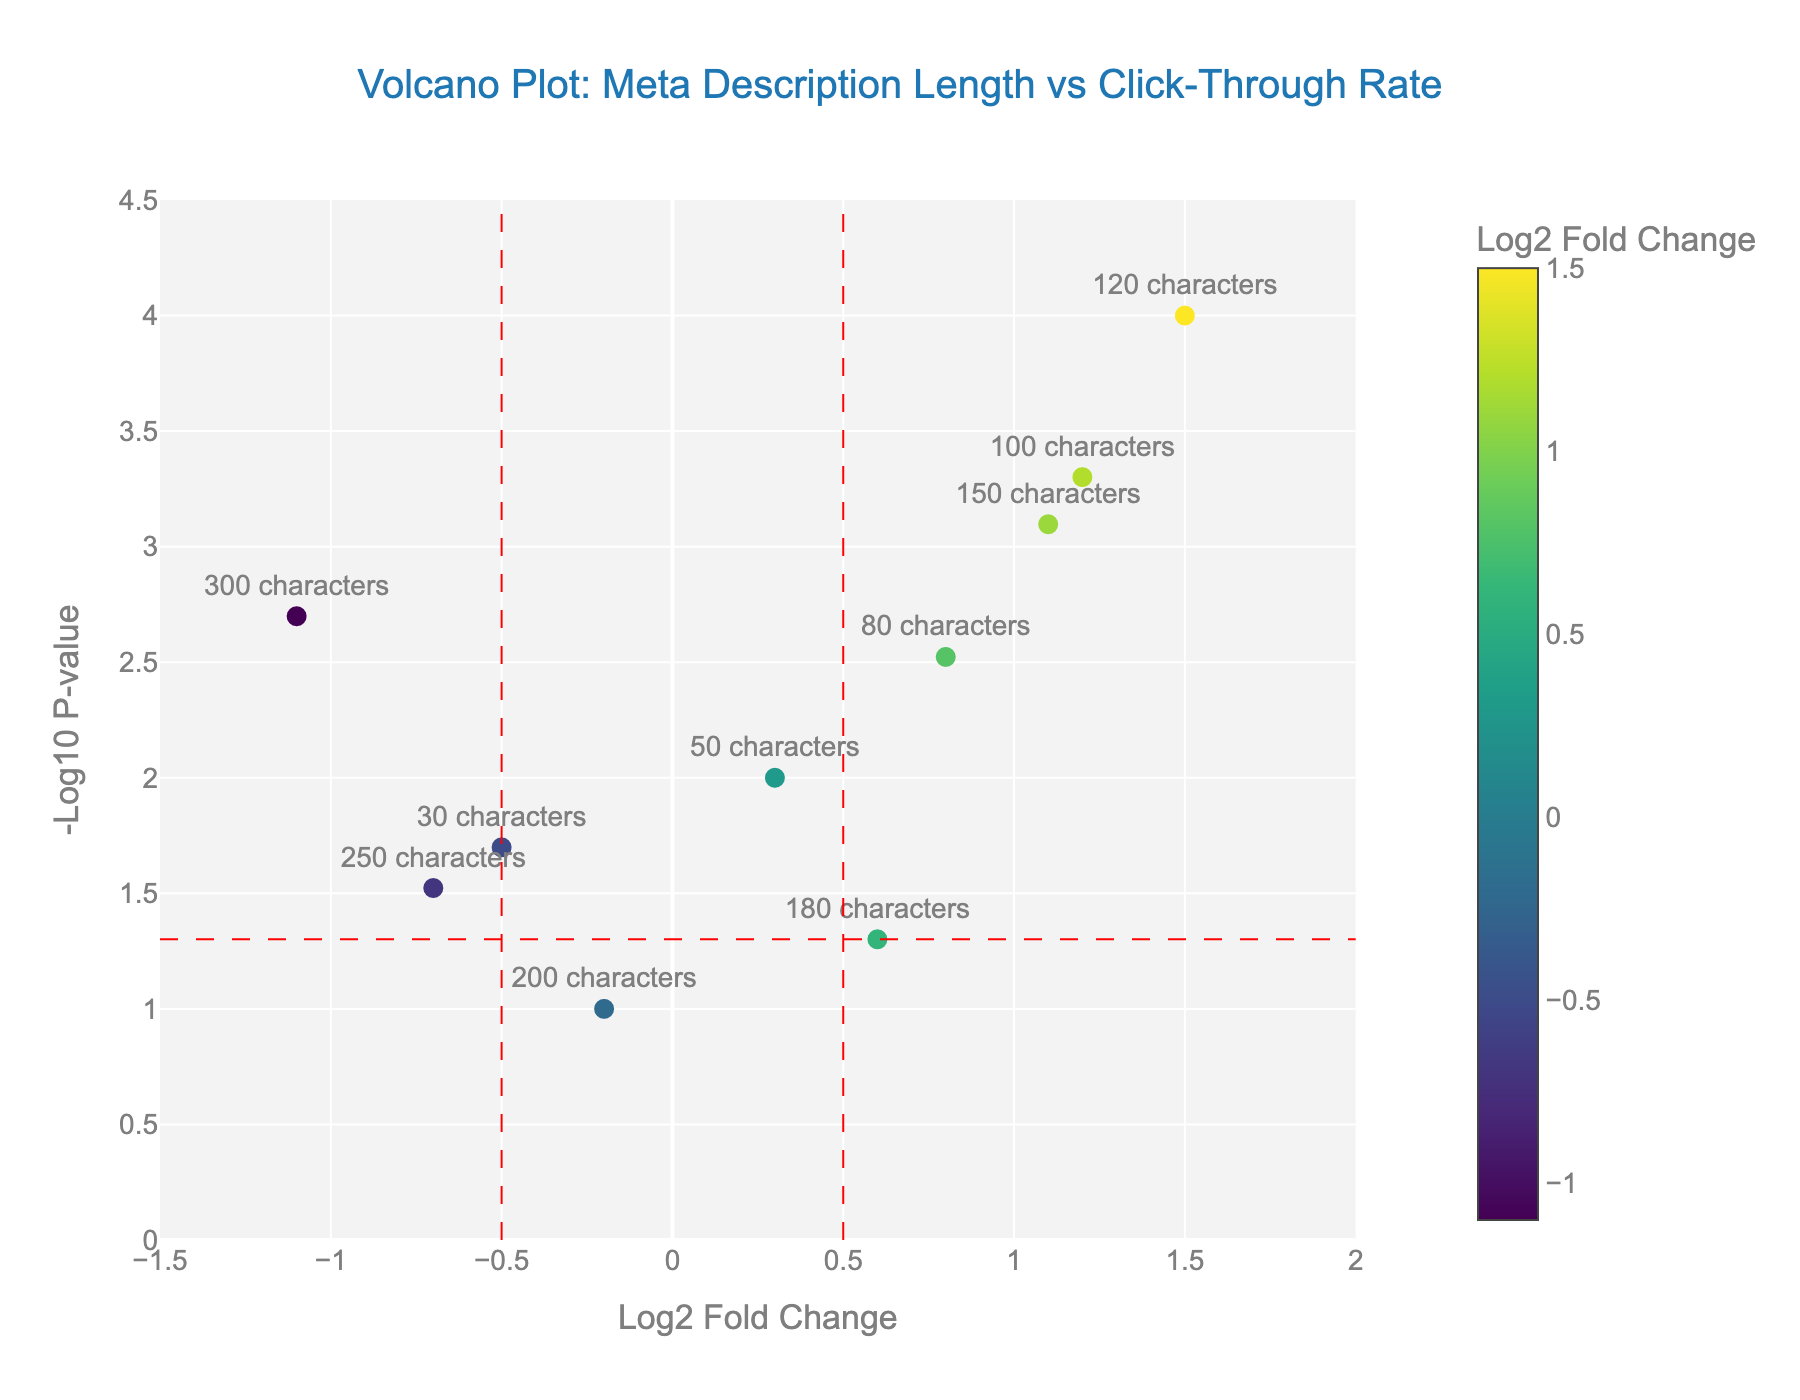What is the title of the plot? The title of the plot is displayed at the top center. In this case, it reads "Volcano Plot: Meta Description Length vs Click-Through Rate".
Answer: Volcano Plot: Meta Description Length vs Click-Through Rate What do the X and Y axes represent in this plot? The x-axis represents the Log2 Fold Change, and the y-axis represents the -Log10 P-value. These are indicated by the labels on the respective axes.
Answer: Log2 Fold Change and -Log10 P-value What color is used to draw the vertical lines at fold change thresholds? The vertical lines at fold change thresholds are drawn in red, which can be observed in the plot.
Answer: Red Which meta description length shows the highest -Log10 P-value? The meta description length that shows the highest -Log10 P-value is 120 characters. This can be observed by looking at the highest point on the y-axis and identifying the corresponding meta description length.
Answer: 120 characters How many data points have a Log2 Fold Change greater than 0.5? Count the data points to the right of the vertical red line at 0.5 on the x-axis. This includes 80, 100, 120, and 150 characters.
Answer: Four Which meta description length has the lowest Log2 Fold Change and what is its corresponding -Log10 P-value? The meta description length with the lowest Log2 Fold Change is 300 characters, as observed on the x-axis, and its corresponding -Log10 P-value can be read off the y-axis, which is approximately 2.7.
Answer: 300 characters, 2.7 Are there any meta description lengths with a Log2 Fold Change less than -0.5 and a -Log10 P-value greater than 1.5? Check for data points to the left of -0.5 on the x-axis and above 1.5 on the y-axis. The 30 characters and 250 characters points meet these criteria.
Answer: Yes Which meta description length appears to be the least effective in terms of click-through rate based on its Log2 Fold Change? The least effective meta description length is the one with the most negative Log2 Fold Change, which is 300 characters.
Answer: 300 characters 